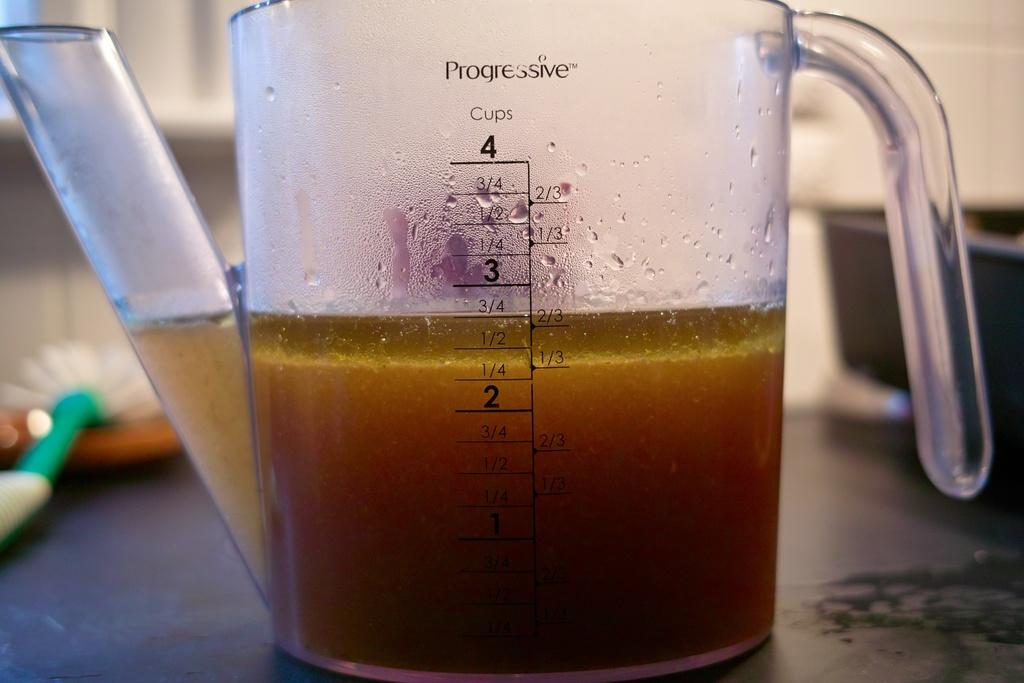<image>
Present a compact description of the photo's key features. A progressive measuring cup is filled with 2 3/4 cups of liquid 